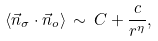<formula> <loc_0><loc_0><loc_500><loc_500>\langle \vec { n } _ { \sigma } \cdot \vec { n } _ { o } \rangle \, \sim \, C + \frac { c } { r ^ { \eta } } ,</formula> 